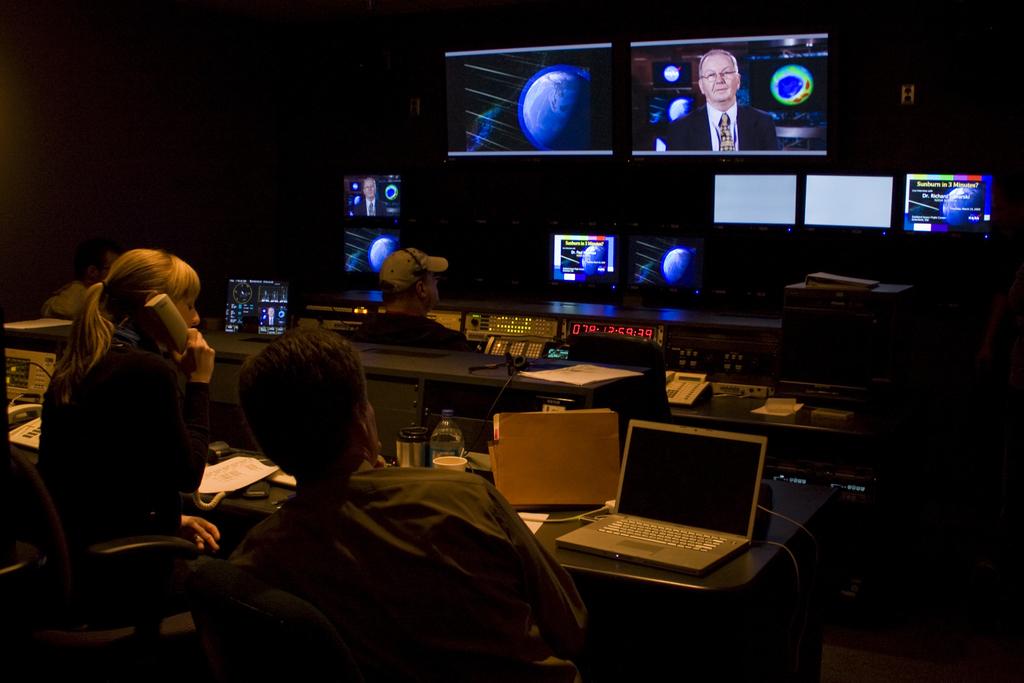What time is it at the moment during the show?
Your answer should be compact. 12:59. 